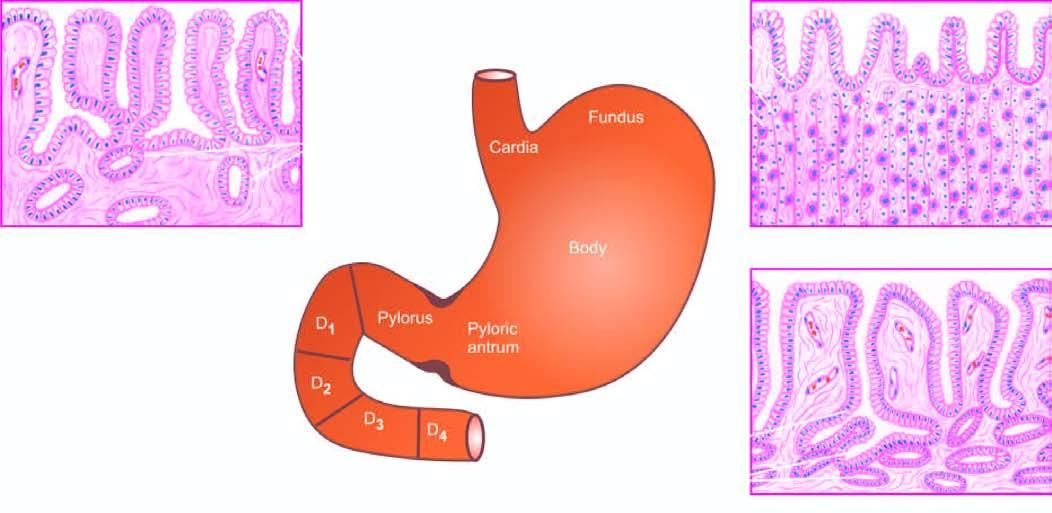re a few well-developed cell nests with keratinisation correlated with histological appearance of gastric mucosa in different regions?
Answer the question using a single word or phrase. No 